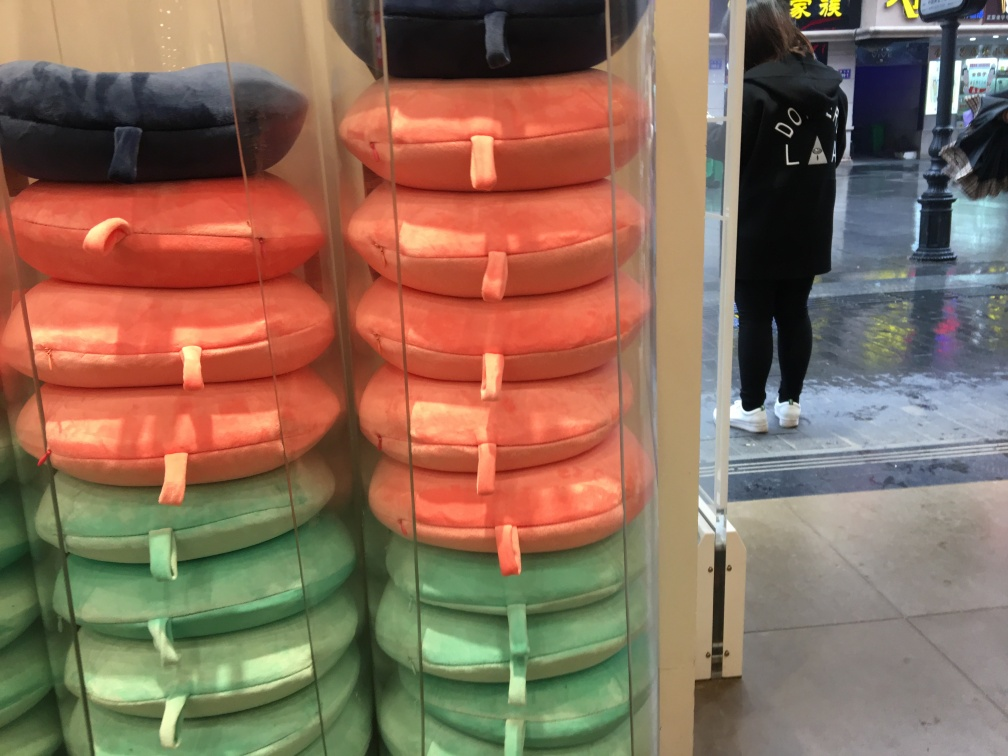Can you tell me about the products shown in the image? Certainly! This image displays a selection of travel neck pillows stacked on shelves, in an array of colors such as dark blue, salmon pink, and turquoise. These pillows are designed to support the neck while traveling, commonly used by passengers during long flights or car rides for added comfort. 